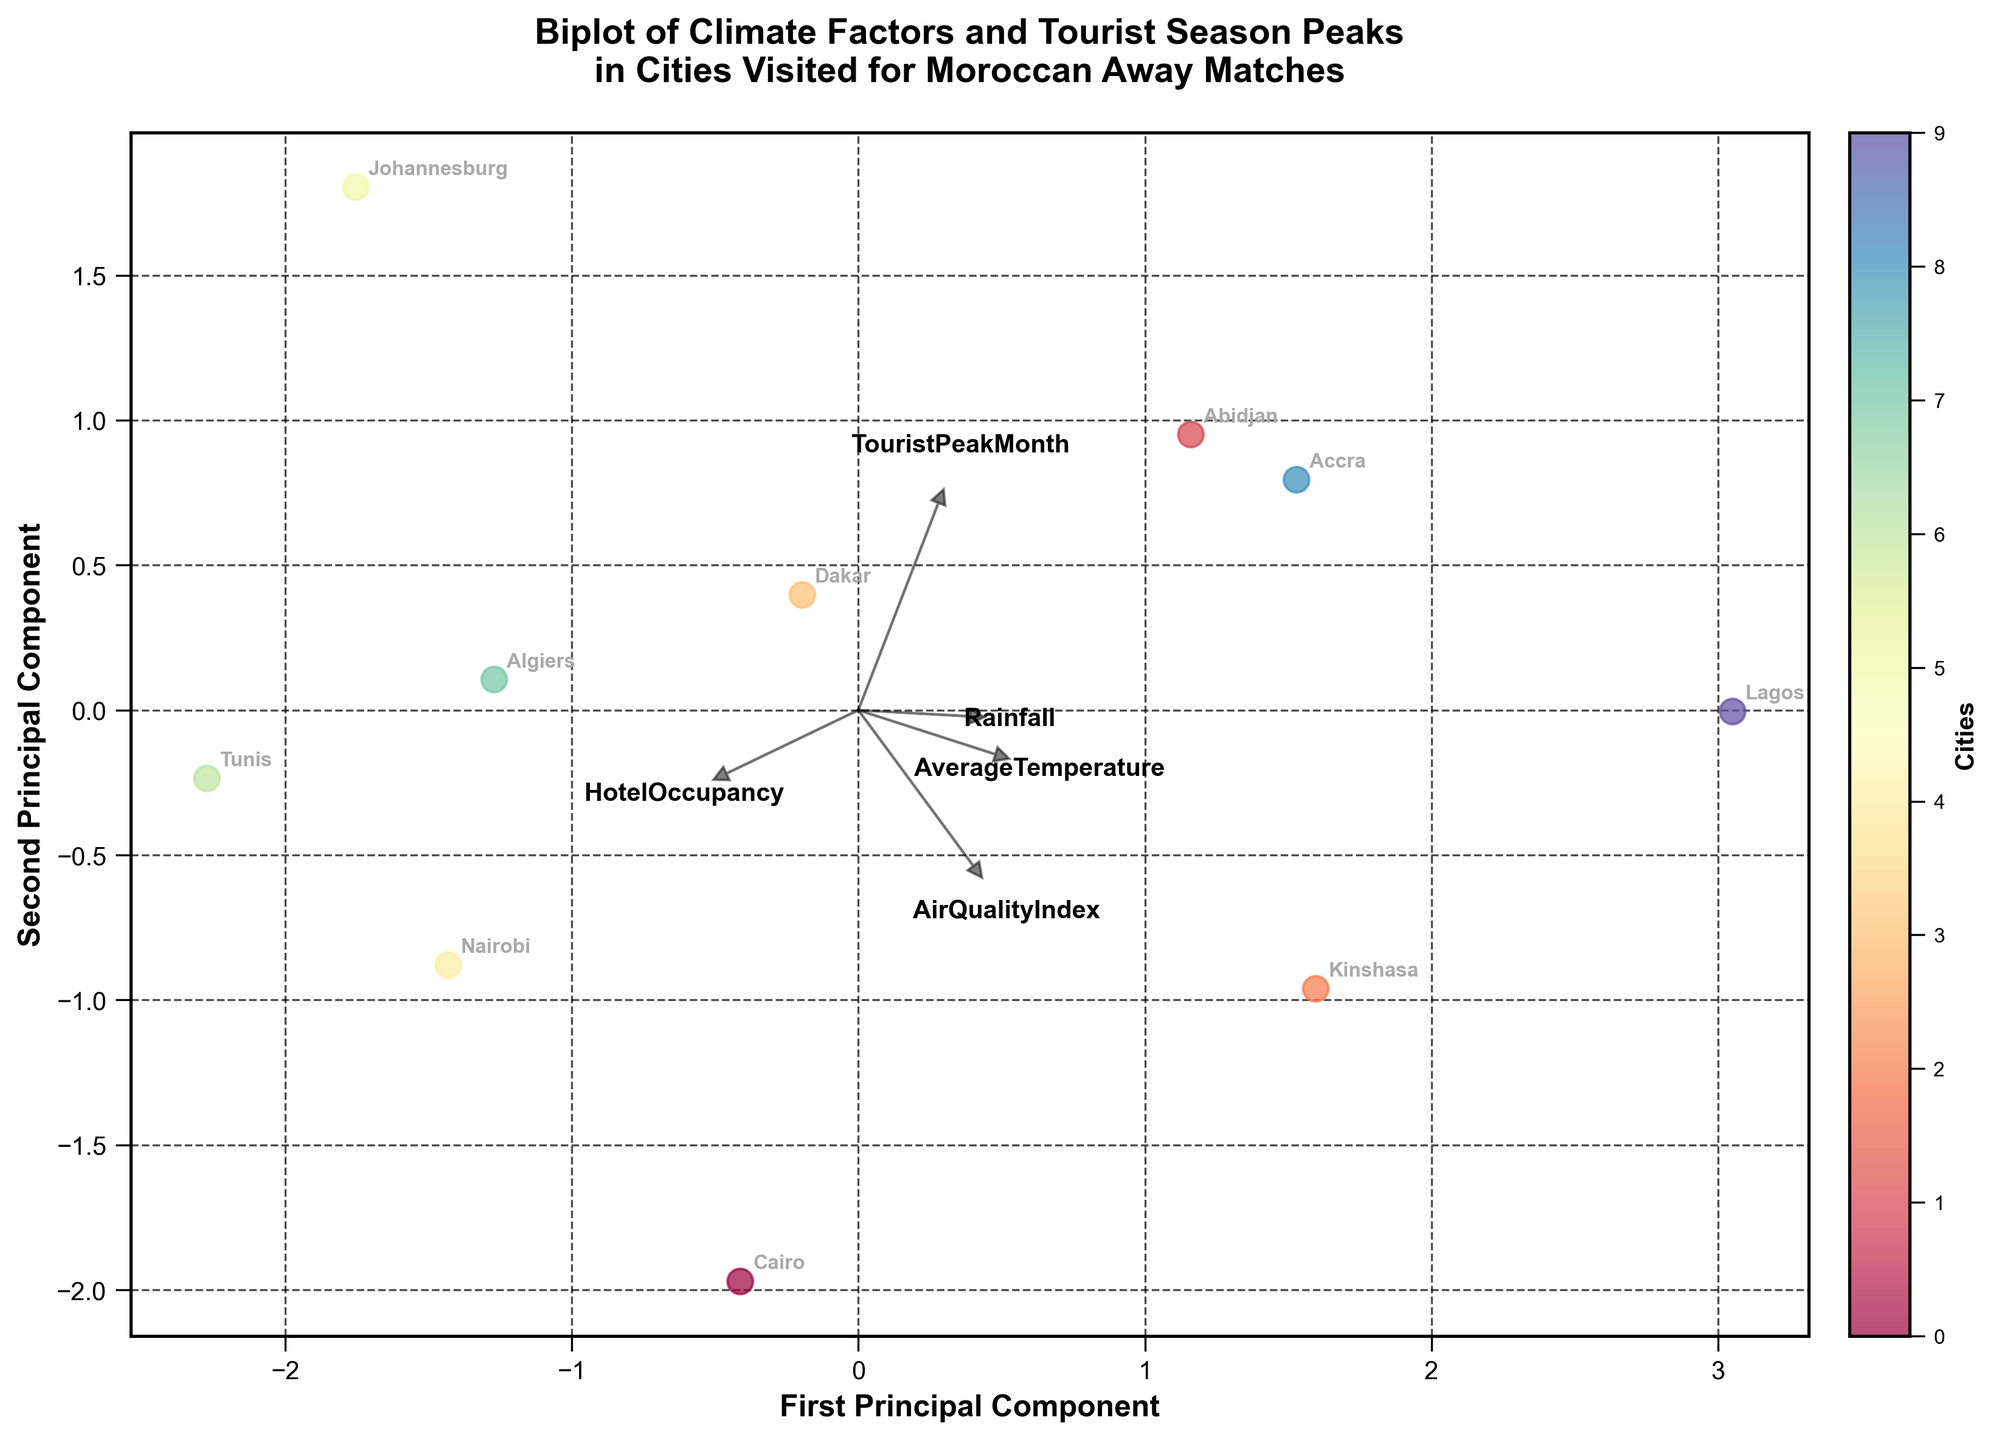What's the title of the plot? The title is written at the top of the plot in bold text. It summarizes what the plot represents.
Answer: Biplot of Climate Factors and Tourist Season Peaks in Cities Visited for Moroccan Away Matches How many data points (cities) are shown in the biplot? Each city is represented as a point annotated with its name in the biplot. Counting each annotated point will give you the total number of data points.
Answer: 10 Which city has the highest HotelOccupancy rate? The feature vectors indicate the direction and magnitude of each factor. The city with its point closest to the HotelOccupancy vector is the one with the highest rate.
Answer: Tunis Which city's data point appears closest to the AirQualityIndex vector? Look at the direction of the AirQualityIndex vector; the city whose data point lies closest to this vector's path has the highest AirQualityIndex.
Answer: Lagos What are the names of cities with TouristPeakMonth in December? Find the position of the TouristPeakMonth vector and identify the cities whose data points are closest to the vector corresponding to December.
Answer: Abidjan, Johannesburg, Accra, Lagos Which city has the lowest Rainfall, and how can you tell from the biplot? Check the direction of the Rainfall vector and look for the city that lies farthest in the opposite direction of this vector. This city represents the lowest Rainfall.
Answer: Cairo How does Nairobi compare to Johannesburg in terms of AverageTemperature? Examine the direction of the AverageTemperature vector. Nairobi and Johannesburg's positions relative to this vector will show their comparative AverageTemperature. Nairobi is farther along the direction of the AverageTemperature vector than Johannesburg, indicating a higher AverageTemperature.
Answer: Nairobi has a higher average temperature than Johannesburg Which cities are highly correlated with the feature Rainfall? The cities that lie in the same direction as the Rainfall vector and are close to it on the biplot have high values of Rainfall, indicating a high correlation.
Answer: Abidjan, Kinshasa, Lagos If three features explain a lot of variance among the cities’ climate and tourist data, which three may these be and why? Look for the feature vectors that have the greatest distances and span when plotted. They are likely the most important because they explain the most variance in the data. AverageTemperature, Rainfall, and TouristPeakMonth have significant spans and separation in the plot, making them likely candidates.
Answer: AverageTemperature, Rainfall, TouristPeakMonth Based on the plot, which features appear to be inversely related? Features that have arrows pointing in opposite directions on the biplot are inversely related. Observe the angles between vectors to identify these relationships.
Answer: AverageTemperature and AirQualityIndex 